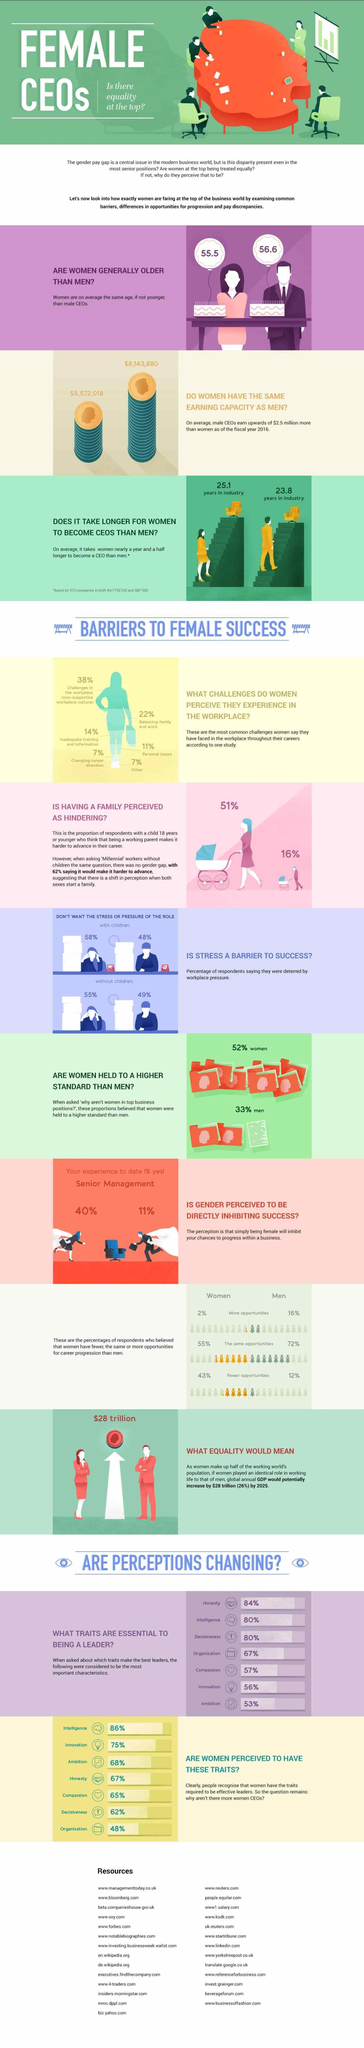Identify some key points in this picture. On average, female CEOs earn approximately $5,572,018 per year. Research has identified a total of 7 key traits that are considered essential to being a leader. On average, males in industry take 23.8 years to reach the position of CEO. On average, it takes females in industry 25.1 years to reach the position of a CEO. According to the survey, 48% of males with children do not want the stress or pressure associated with the role of a stay-at-home parent. 